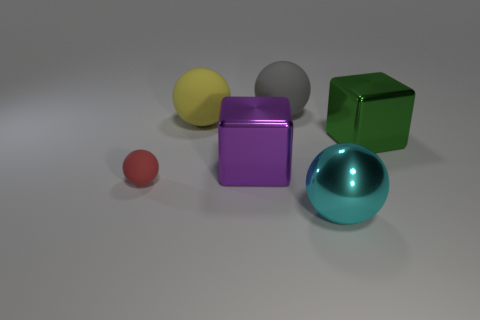What material is the large yellow thing that is the same shape as the cyan object?
Offer a very short reply. Rubber. There is a tiny rubber object that is in front of the large purple object that is on the right side of the small red rubber object; what number of large metallic things are in front of it?
Provide a short and direct response. 1. How big is the purple shiny thing?
Give a very brief answer. Large. What is the size of the matte thing that is in front of the purple object?
Provide a succinct answer. Small. What number of other things are the same shape as the big gray rubber object?
Give a very brief answer. 3. Is the number of big purple metallic blocks that are in front of the big green block the same as the number of green blocks that are behind the large yellow object?
Offer a terse response. No. Do the big cube left of the green metallic thing and the green object to the right of the large cyan metal object have the same material?
Make the answer very short. Yes. How many other things are the same size as the gray matte sphere?
Make the answer very short. 4. How many objects are large yellow matte spheres or shiny objects left of the large cyan metal sphere?
Offer a terse response. 2. Are there an equal number of big cyan things that are behind the big purple thing and yellow metallic cubes?
Provide a succinct answer. Yes. 